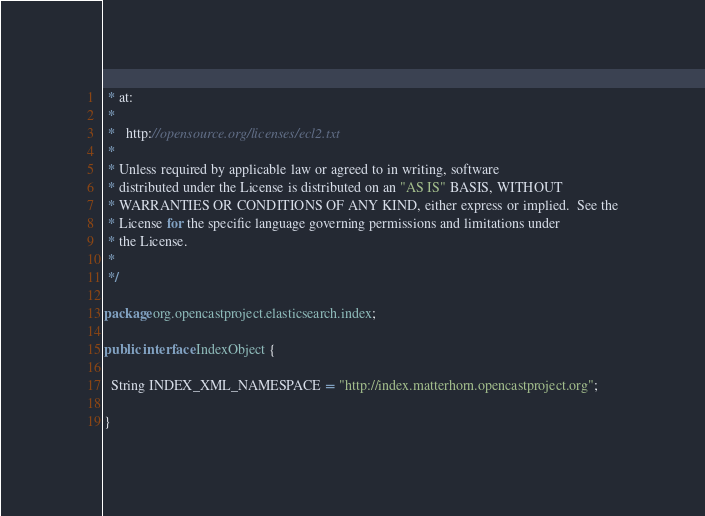<code> <loc_0><loc_0><loc_500><loc_500><_Java_> * at:
 *
 *   http://opensource.org/licenses/ecl2.txt
 *
 * Unless required by applicable law or agreed to in writing, software
 * distributed under the License is distributed on an "AS IS" BASIS, WITHOUT
 * WARRANTIES OR CONDITIONS OF ANY KIND, either express or implied.  See the
 * License for the specific language governing permissions and limitations under
 * the License.
 *
 */

package org.opencastproject.elasticsearch.index;

public interface IndexObject {

  String INDEX_XML_NAMESPACE = "http://index.matterhorn.opencastproject.org";

}
</code> 